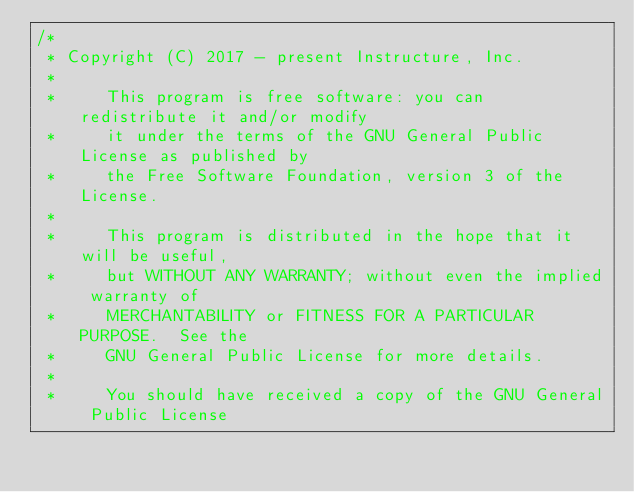Convert code to text. <code><loc_0><loc_0><loc_500><loc_500><_Kotlin_>/*
 * Copyright (C) 2017 - present Instructure, Inc.
 *
 *     This program is free software: you can redistribute it and/or modify
 *     it under the terms of the GNU General Public License as published by
 *     the Free Software Foundation, version 3 of the License.
 *
 *     This program is distributed in the hope that it will be useful,
 *     but WITHOUT ANY WARRANTY; without even the implied warranty of
 *     MERCHANTABILITY or FITNESS FOR A PARTICULAR PURPOSE.  See the
 *     GNU General Public License for more details.
 *
 *     You should have received a copy of the GNU General Public License</code> 